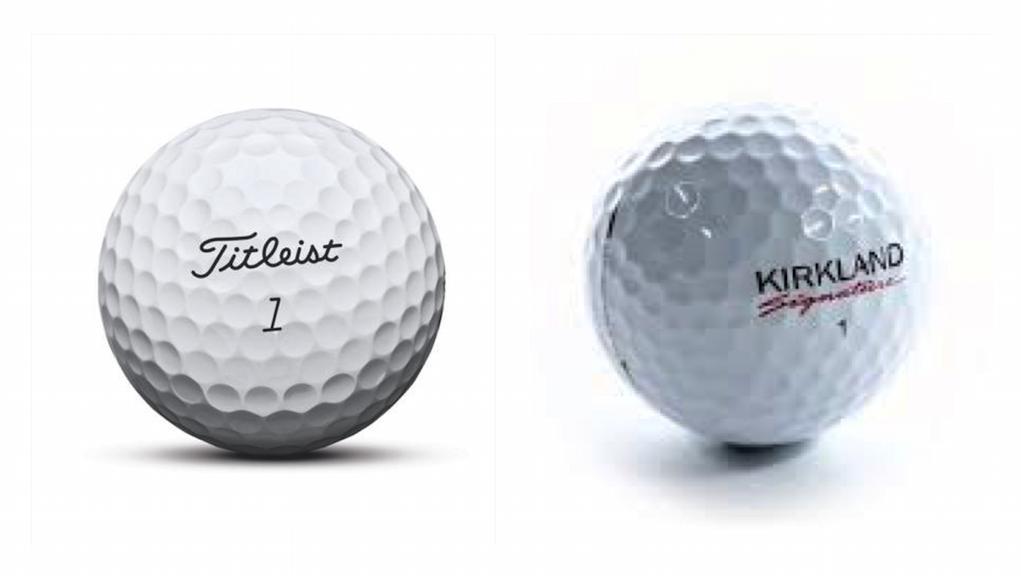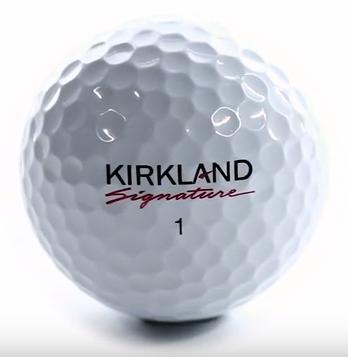The first image is the image on the left, the second image is the image on the right. Considering the images on both sides, is "There are three golf balls" valid? Answer yes or no. Yes. 